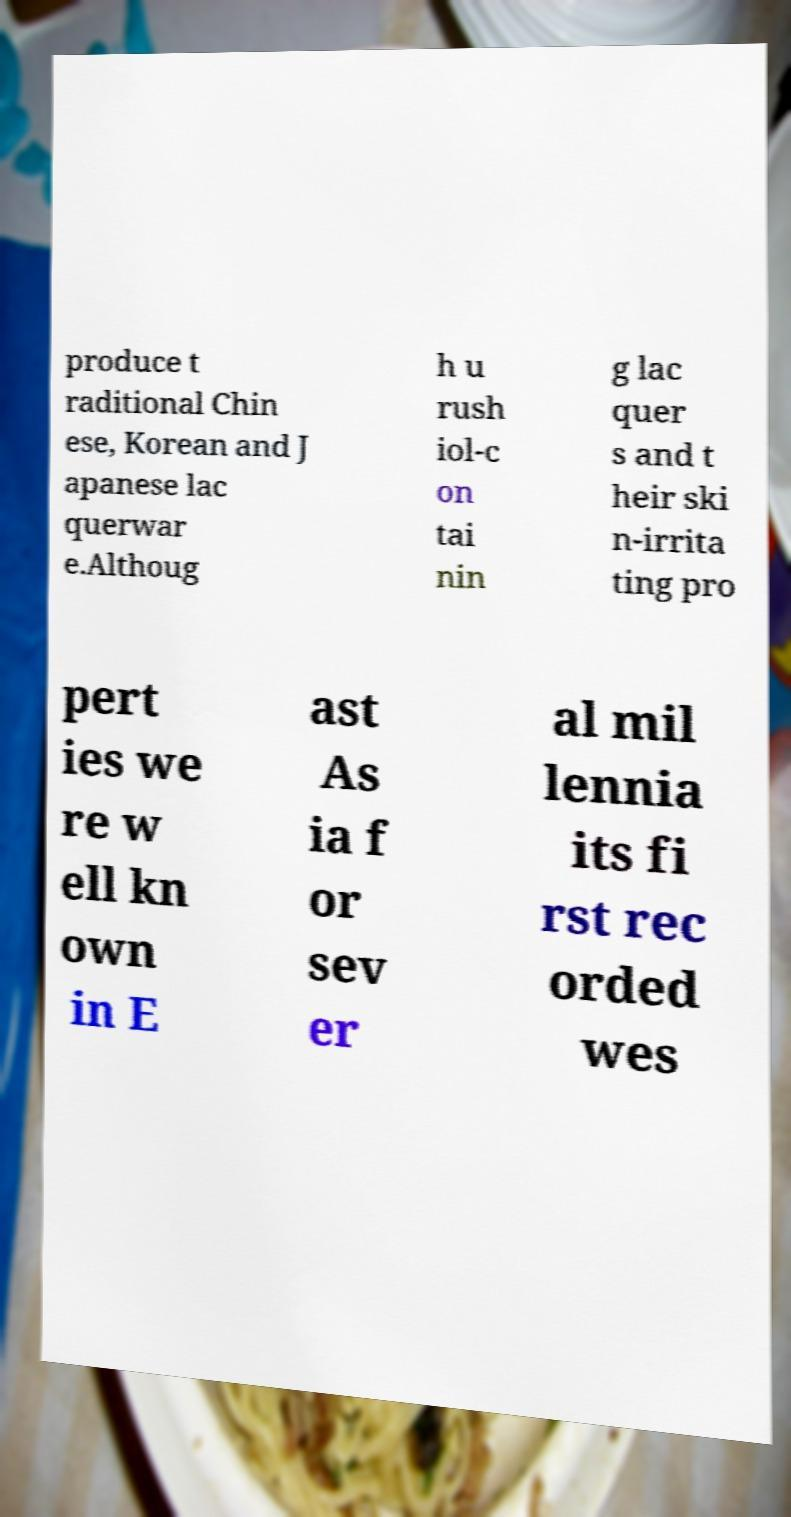There's text embedded in this image that I need extracted. Can you transcribe it verbatim? produce t raditional Chin ese, Korean and J apanese lac querwar e.Althoug h u rush iol-c on tai nin g lac quer s and t heir ski n-irrita ting pro pert ies we re w ell kn own in E ast As ia f or sev er al mil lennia its fi rst rec orded wes 